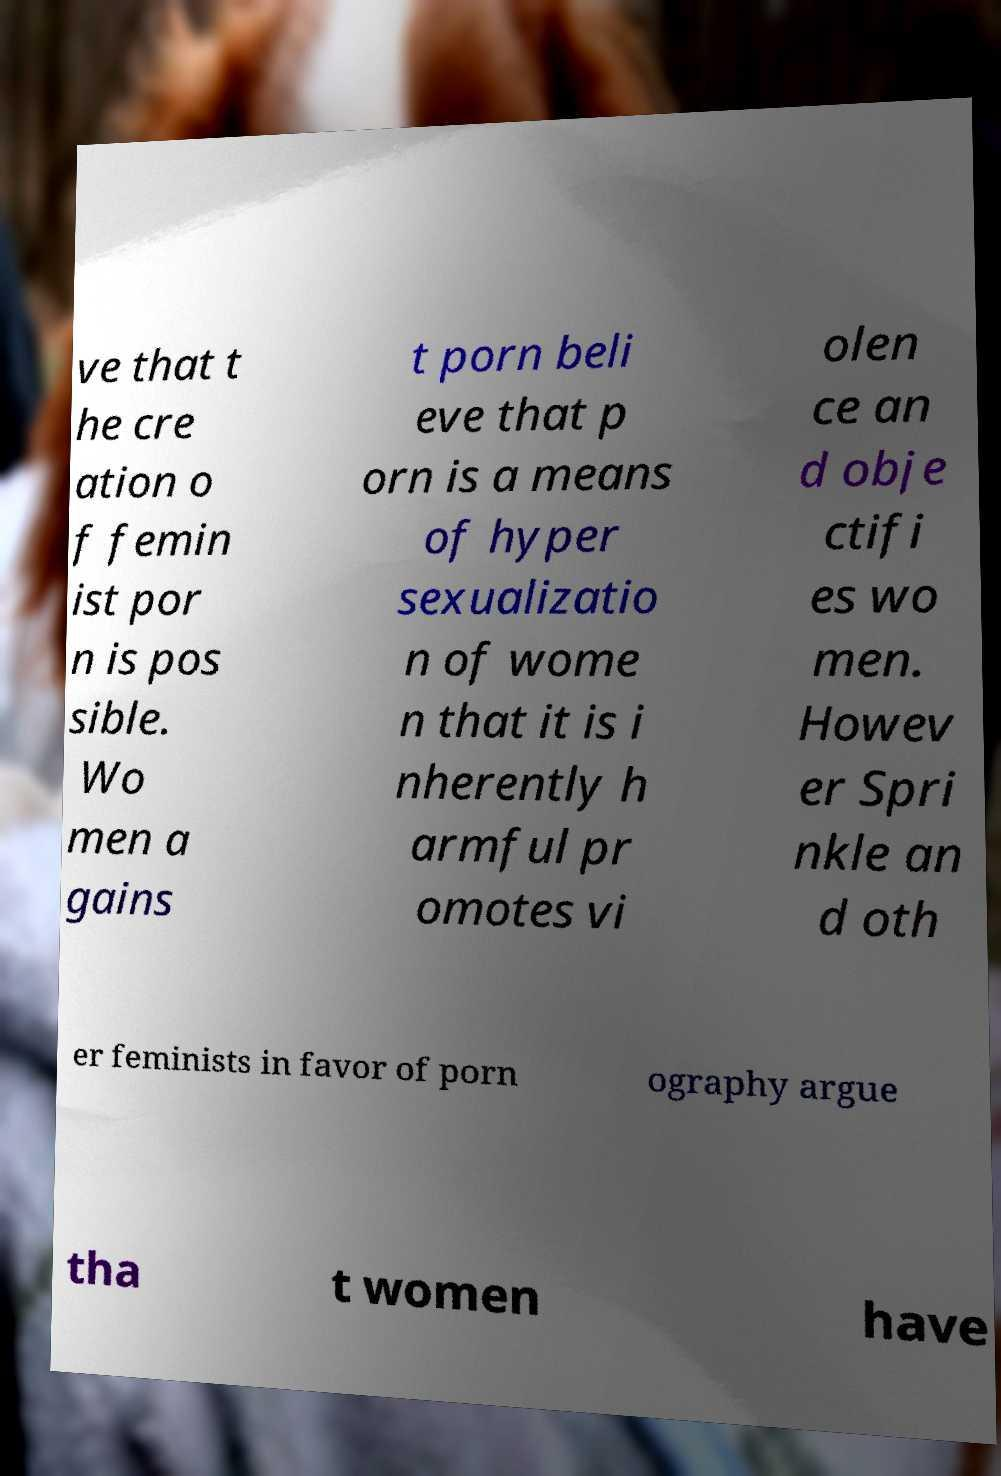There's text embedded in this image that I need extracted. Can you transcribe it verbatim? ve that t he cre ation o f femin ist por n is pos sible. Wo men a gains t porn beli eve that p orn is a means of hyper sexualizatio n of wome n that it is i nherently h armful pr omotes vi olen ce an d obje ctifi es wo men. Howev er Spri nkle an d oth er feminists in favor of porn ography argue tha t women have 